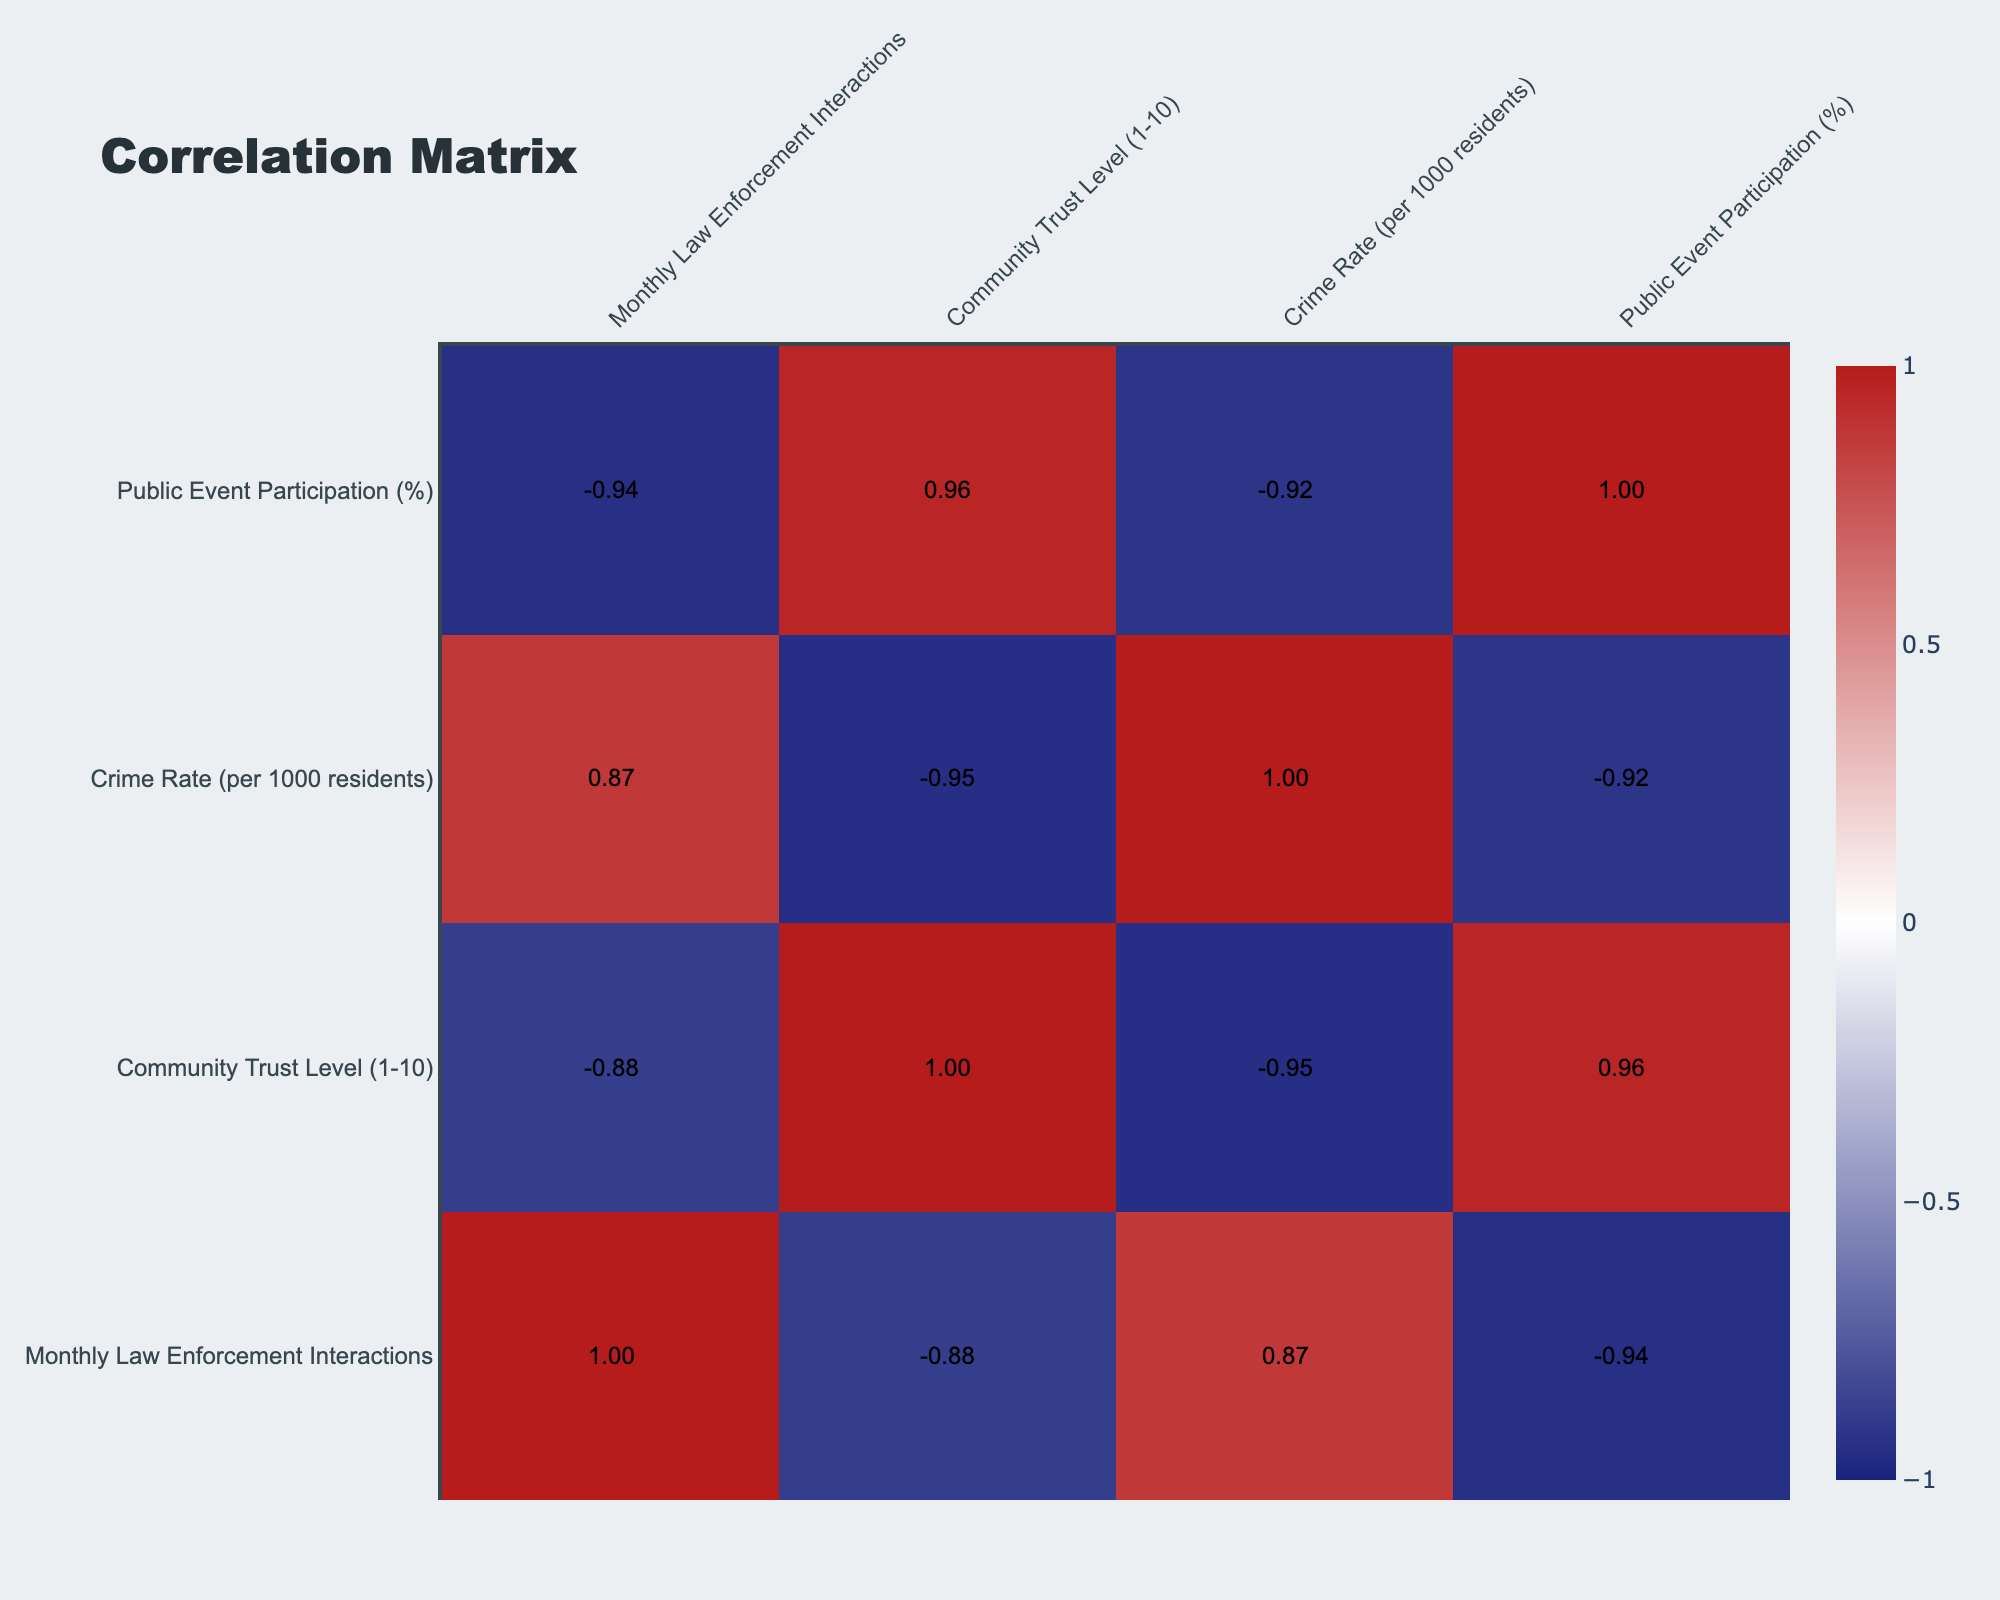What is the community with the highest number of monthly law enforcement interactions? By scanning the "Monthly Law Enforcement Interactions" column, Pine Hill has the highest value of 25, making it the community with the most interactions.
Answer: Pine Hill What is the community trust level of Mapleton? Looking at the "Community Trust Level" column, Mapleton has a trust level of 9.
Answer: 9 Is there a correlation between monthly law enforcement interactions and community trust levels? By observing the correlation coefficient in the cell where "Monthly Law Enforcement Interactions" intersects with "Community Trust Level", the value is -0.85, indicating a strong negative correlation.
Answer: Yes What is the average crime rate across all communities listed? Summing the crime rates (3.5 + 4.2 + 2.8 + 3.9 + 5.0 + 2.5 + 4.8 + 3.2 + 6.1 + 3.0) = 34.0, and dividing by the number of communities (10), gives an average of 3.4.
Answer: 3.4 Which community has the lowest community trust level? By examining the "Community Trust Level" column, Greenfield has the lowest score of 4.
Answer: Greenfield What is the difference in community trust levels between Cedarwood and Silver Oaks? The trust level for Cedarwood is 8, while for Silver Oaks it is 3. Therefore, the difference is 8 - 3 = 5.
Answer: 5 Is there a community with both high law enforcement interactions and high community trust? The only community with a high interaction (above 15) and a trust level above 6 is Meadow Springs, which has 14 interactions and trust level 6.
Answer: No What is the community participation percentage for the community with the highest crime rate? Pine Hill has the highest crime rate of 6.1, and looking at the "Public Event Participation" column, it corresponds to a participation percentage of 10%.
Answer: 10% Are there any communities where the crime rate is above 4 but the community trust level is also above 6? By scanning the table, Greenfield has a crime rate of 5.0 but a trust level of 4, and Brookfield has a crime rate of 4.2 and a trust level of 5. Hence, there are no communities meeting both criteria.
Answer: No 